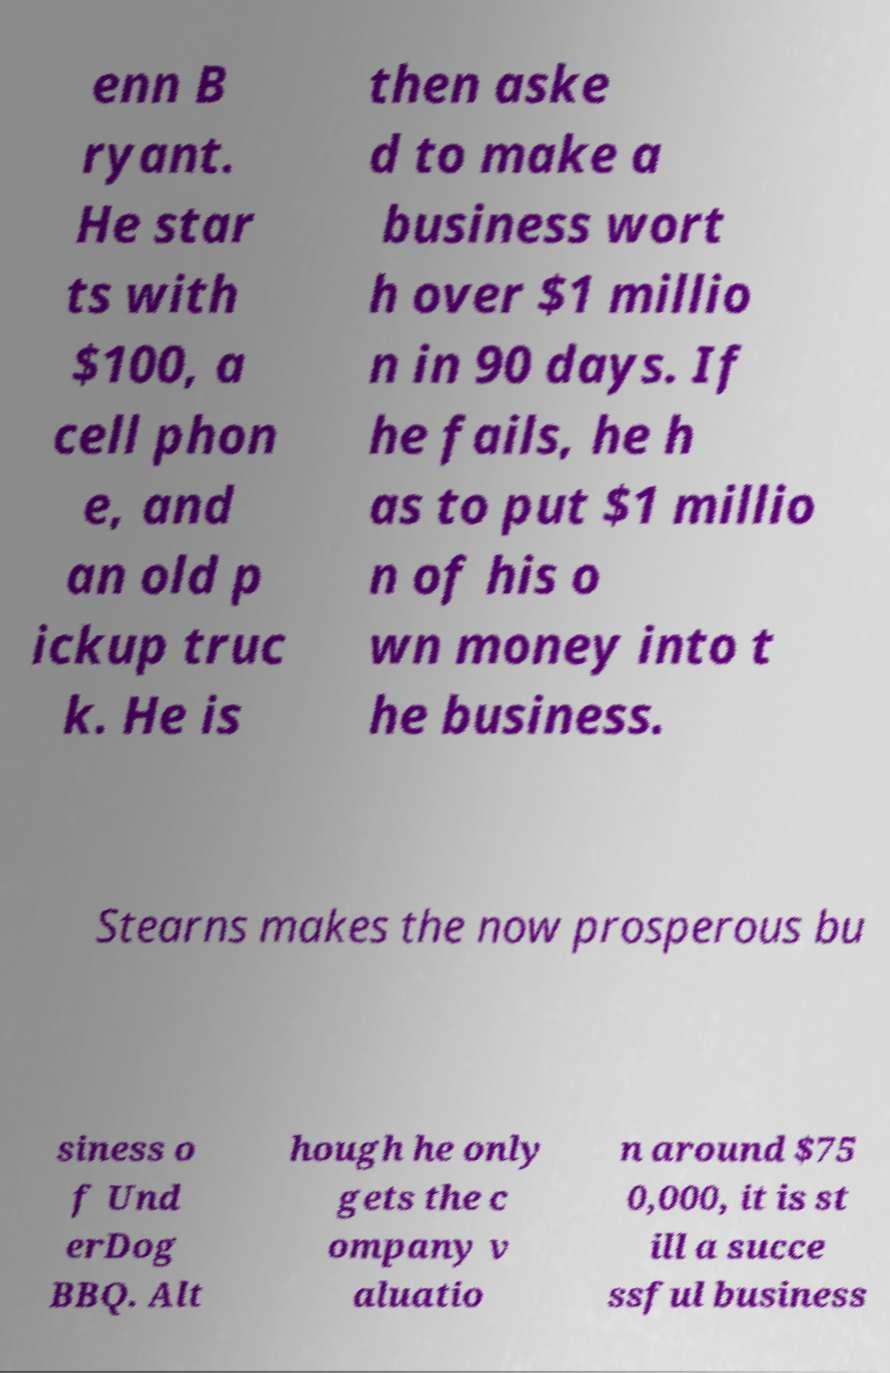There's text embedded in this image that I need extracted. Can you transcribe it verbatim? enn B ryant. He star ts with $100, a cell phon e, and an old p ickup truc k. He is then aske d to make a business wort h over $1 millio n in 90 days. If he fails, he h as to put $1 millio n of his o wn money into t he business. Stearns makes the now prosperous bu siness o f Und erDog BBQ. Alt hough he only gets the c ompany v aluatio n around $75 0,000, it is st ill a succe ssful business 